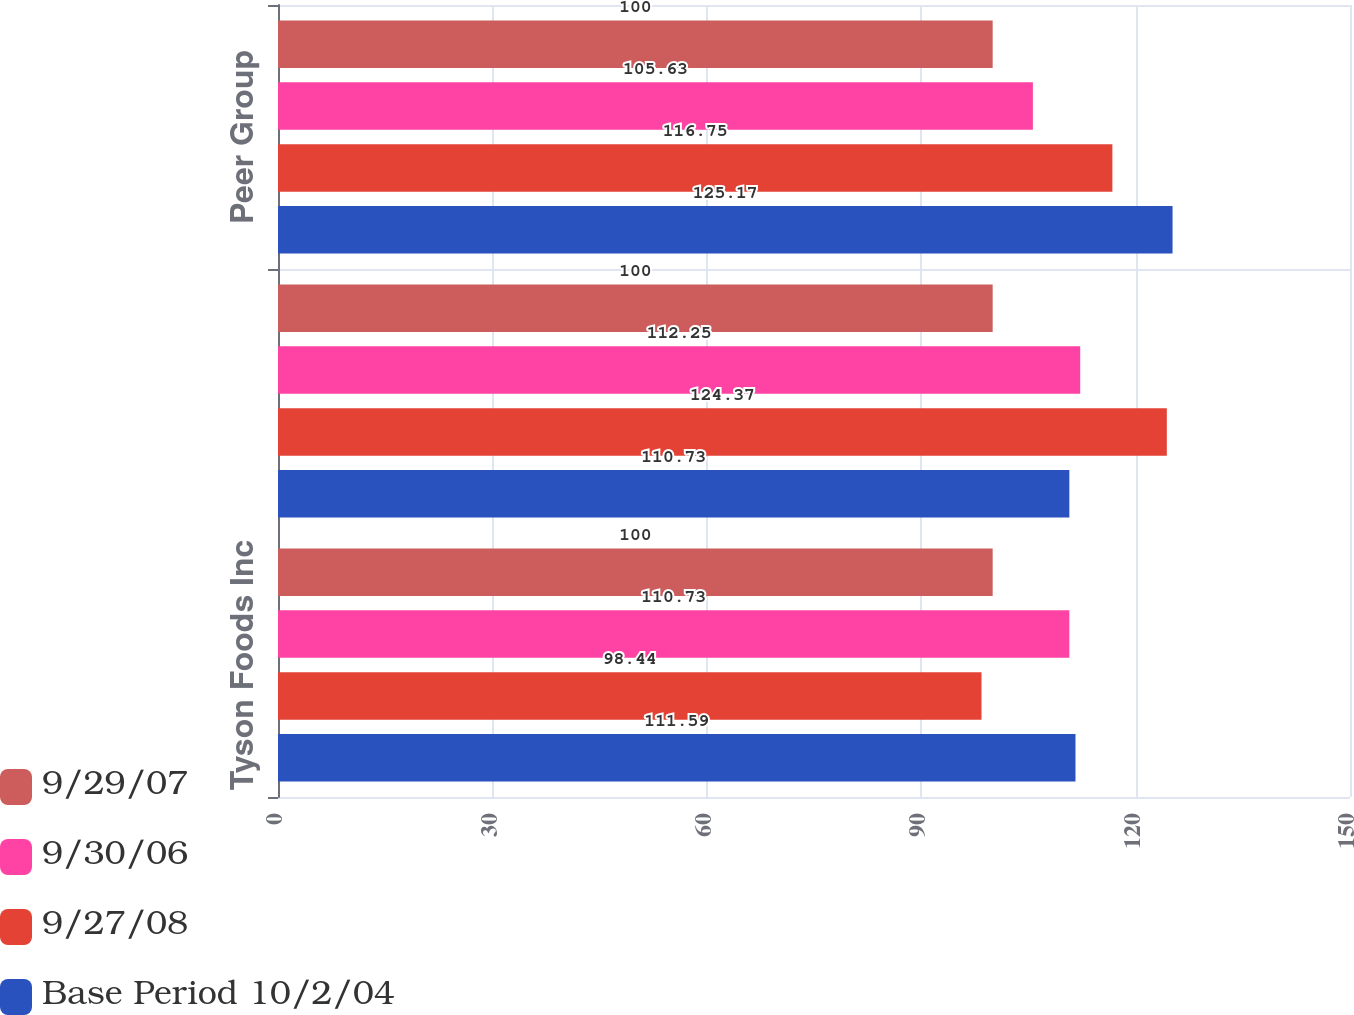Convert chart. <chart><loc_0><loc_0><loc_500><loc_500><stacked_bar_chart><ecel><fcel>Tyson Foods Inc<fcel>S&P 500 Index<fcel>Peer Group<nl><fcel>9/29/07<fcel>100<fcel>100<fcel>100<nl><fcel>9/30/06<fcel>110.73<fcel>112.25<fcel>105.63<nl><fcel>9/27/08<fcel>98.44<fcel>124.37<fcel>116.75<nl><fcel>Base Period 10/2/04<fcel>111.59<fcel>110.73<fcel>125.17<nl></chart> 